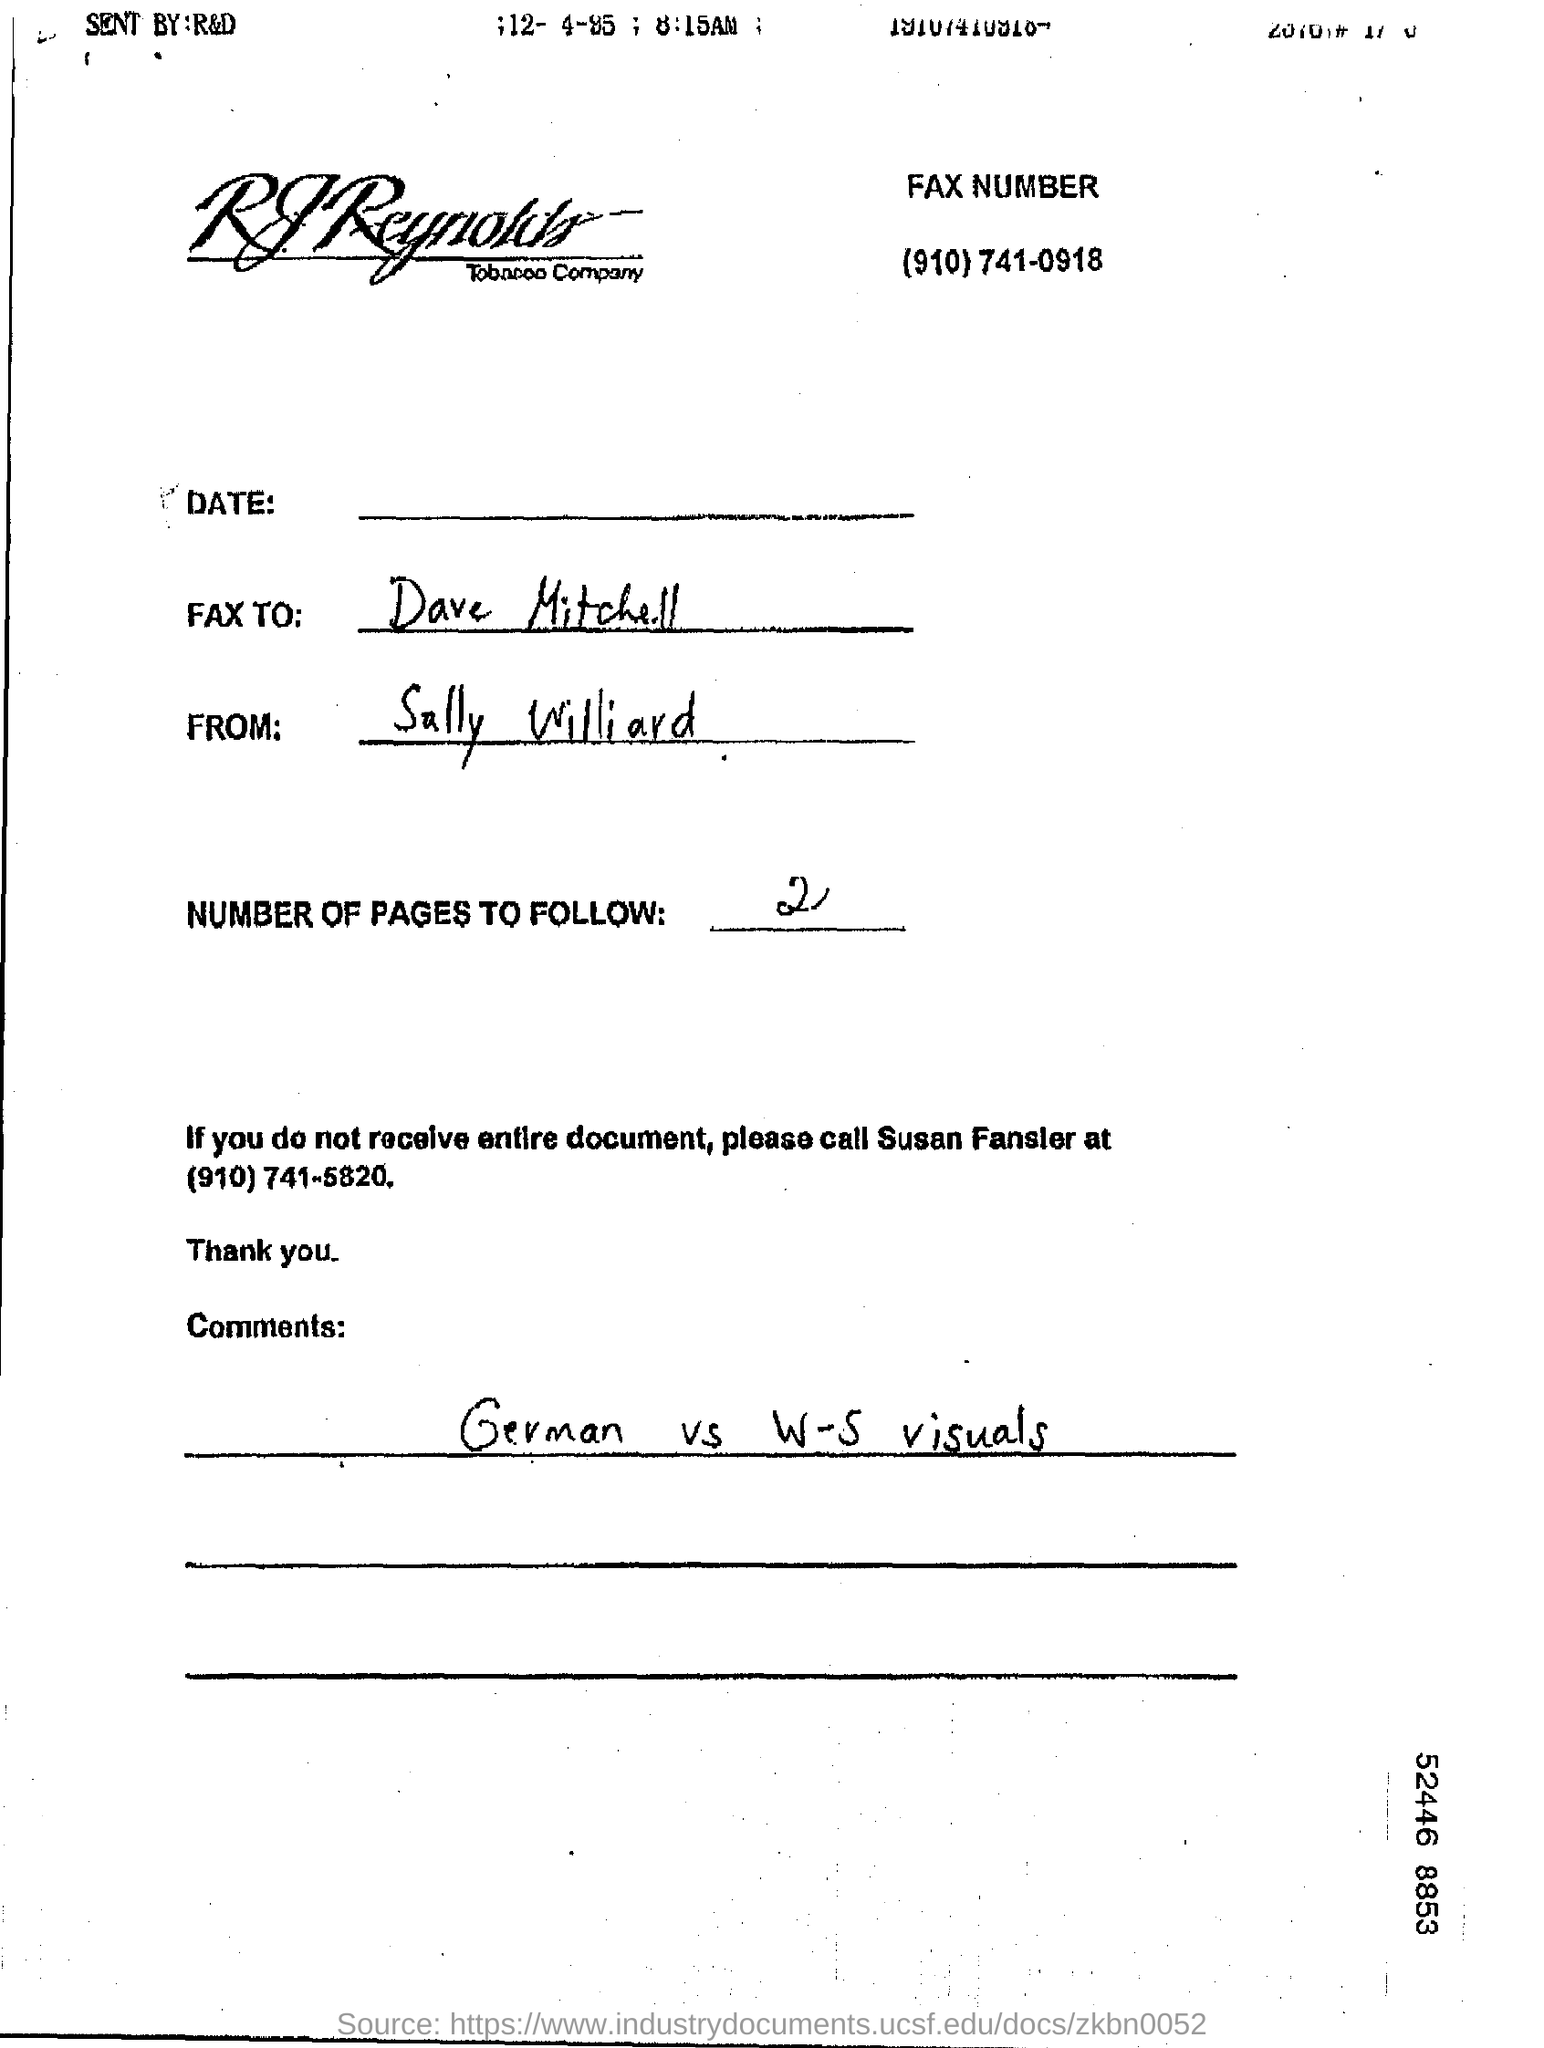Highlight a few significant elements in this photo. The sender of the FAX is Sally Williard. The fax number given is (910)741-0918. The comments mentioned are "German vs W-S visuals. The number of pages to follow is 2.. 